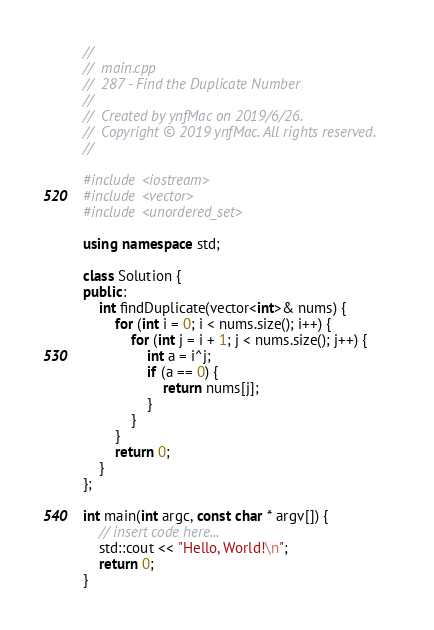Convert code to text. <code><loc_0><loc_0><loc_500><loc_500><_C++_>//
//  main.cpp
//  287 - Find the Duplicate Number
//
//  Created by ynfMac on 2019/6/26.
//  Copyright © 2019 ynfMac. All rights reserved.
//

#include <iostream>
#include <vector>
#include <unordered_set>

using namespace std;

class Solution {
public:
    int findDuplicate(vector<int>& nums) {
        for (int i = 0; i < nums.size(); i++) {
            for (int j = i + 1; j < nums.size(); j++) {
                int a = i^j;
                if (a == 0) {
                    return nums[j];
                }
            }
        }
        return 0;
    }
};

int main(int argc, const char * argv[]) {
    // insert code here...
    std::cout << "Hello, World!\n";
    return 0;
}
</code> 